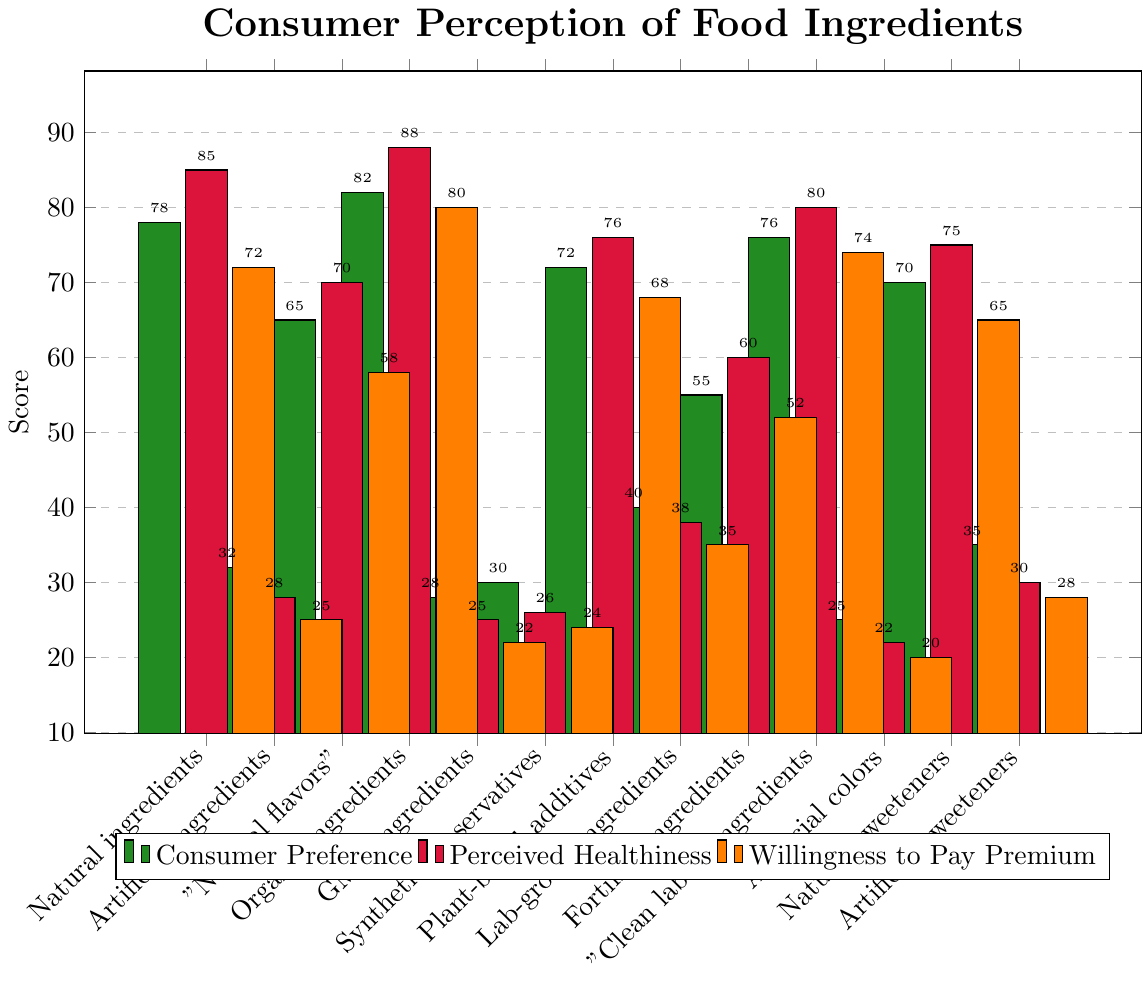What ingredient type has the highest consumer preference score? The bar corresponding to "Organic ingredients" in green is the tallest in the consumer preference category.
Answer: Organic ingredients How does the willingness to pay a premium for artificial sweeteners compare to willingness to pay a premium for natural sweeteners? The bar for "Artificial sweeteners" is visibly shorter than the bar for "Natural sweeteners" in the orange category.
Answer: Natural sweeteners score higher What is the average consumer preference score for natural sweeteners, organic ingredients, and fortified ingredients? Consumer preference scores are 70 for Natural sweeteners, 82 for Organic ingredients, and 55 for Fortified ingredients. The average is calculated as (70 + 82 + 55) / 3.
Answer: 69 Which ingredient type has the smallest difference between consumer preference and perceived healthiness scores? The differences are as follows: 
- Natural ingredients: 85 - 78 = 7
- Organic ingredients: 88 - 82 = 6 
- Comparing for all, "Lab-grown ingredients" has the smallest difference as 38 - 40 = -2.
Answer: Lab-grown ingredients Are consumers more willing to pay a premium for plant-based additives or lab-grown ingredients? Comparing the orange bars for both, "Plant-based additives" is higher than "Lab-grown ingredients."
Answer: Plant-based additives What's the difference between perceived healthiness scores of GMO ingredients and "Clean label" ingredients? Perceived healthiness scores are 25 for GMO ingredients and 80 for "Clean label" ingredients. The difference is 80 - 25.
Answer: 55 Which types of ingredients have a consumer preference score above 70? Upon visual inspection, the green bars taller than 70 are "Natural ingredients," "Organic ingredients," "Plant-based additives," "Natural sweeteners," and "Clean label" ingredients.
Answer: Natural ingredients, Organic ingredients, Plant-based additives, Natural sweeteners, Clean label ingredients In terms of perceived healthiness, how do synthetic preservatives compare to artificial colors? Synthetic preservatives have a perceived healthiness score of 26, whereas artificial colors score 22.
Answer: Synthetic preservatives score higher Which ingredient type has the closest willingness to pay premium score to fortified ingredients? Fortified ingredients score 52. The closest in orange is "Clean label" ingredients, which score 74 - 52 = 22 points difference.
Answer: "Natural flavors" with 58 